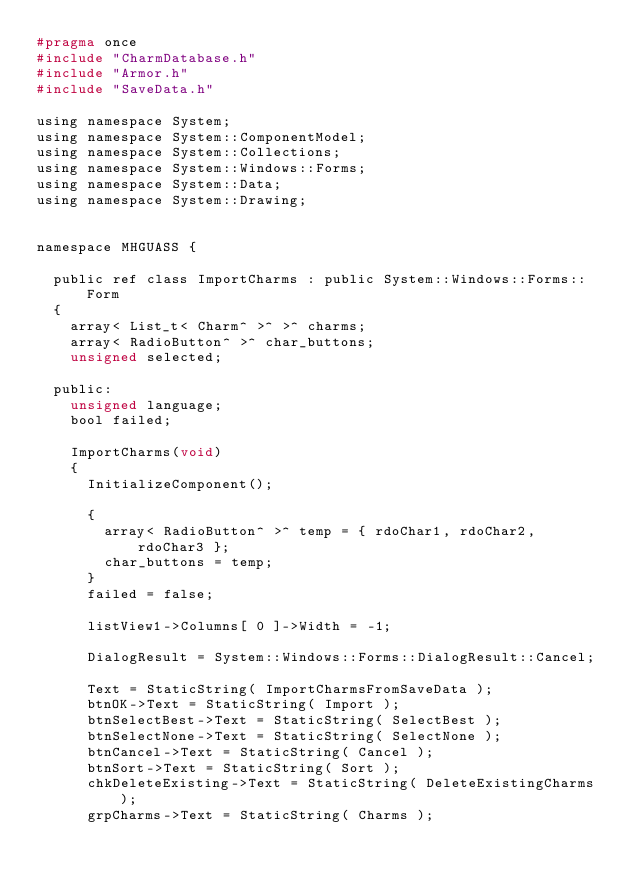<code> <loc_0><loc_0><loc_500><loc_500><_C_>#pragma once
#include "CharmDatabase.h"
#include "Armor.h"
#include "SaveData.h"

using namespace System;
using namespace System::ComponentModel;
using namespace System::Collections;
using namespace System::Windows::Forms;
using namespace System::Data;
using namespace System::Drawing;


namespace MHGUASS {

	public ref class ImportCharms : public System::Windows::Forms::Form
	{
		array< List_t< Charm^ >^ >^ charms;
		array< RadioButton^ >^ char_buttons;
		unsigned selected;

	public:
		unsigned language;
		bool failed;

		ImportCharms(void)
		{
			InitializeComponent();

			{
				array< RadioButton^ >^ temp = { rdoChar1, rdoChar2, rdoChar3 };
				char_buttons = temp;
			}
			failed = false;

			listView1->Columns[ 0 ]->Width = -1;
			
			DialogResult = System::Windows::Forms::DialogResult::Cancel;

			Text = StaticString( ImportCharmsFromSaveData );
			btnOK->Text = StaticString( Import );
			btnSelectBest->Text = StaticString( SelectBest );
			btnSelectNone->Text = StaticString( SelectNone );
			btnCancel->Text = StaticString( Cancel );
			btnSort->Text = StaticString( Sort );
			chkDeleteExisting->Text = StaticString( DeleteExistingCharms );
			grpCharms->Text = StaticString( Charms );</code> 